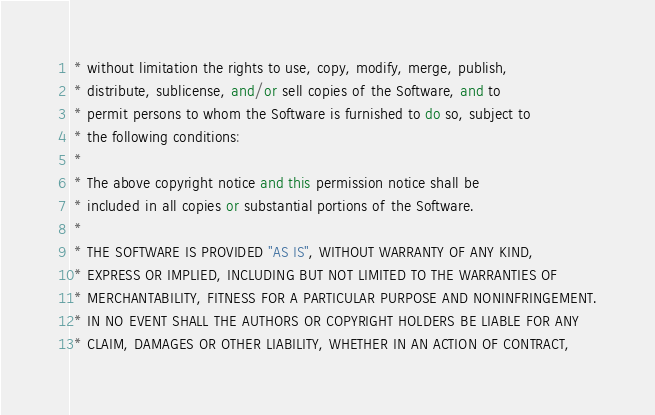Convert code to text. <code><loc_0><loc_0><loc_500><loc_500><_C++_> * without limitation the rights to use, copy, modify, merge, publish,
 * distribute, sublicense, and/or sell copies of the Software, and to
 * permit persons to whom the Software is furnished to do so, subject to
 * the following conditions:
 *
 * The above copyright notice and this permission notice shall be
 * included in all copies or substantial portions of the Software.
 *
 * THE SOFTWARE IS PROVIDED "AS IS", WITHOUT WARRANTY OF ANY KIND,
 * EXPRESS OR IMPLIED, INCLUDING BUT NOT LIMITED TO THE WARRANTIES OF
 * MERCHANTABILITY, FITNESS FOR A PARTICULAR PURPOSE AND NONINFRINGEMENT.
 * IN NO EVENT SHALL THE AUTHORS OR COPYRIGHT HOLDERS BE LIABLE FOR ANY
 * CLAIM, DAMAGES OR OTHER LIABILITY, WHETHER IN AN ACTION OF CONTRACT,</code> 